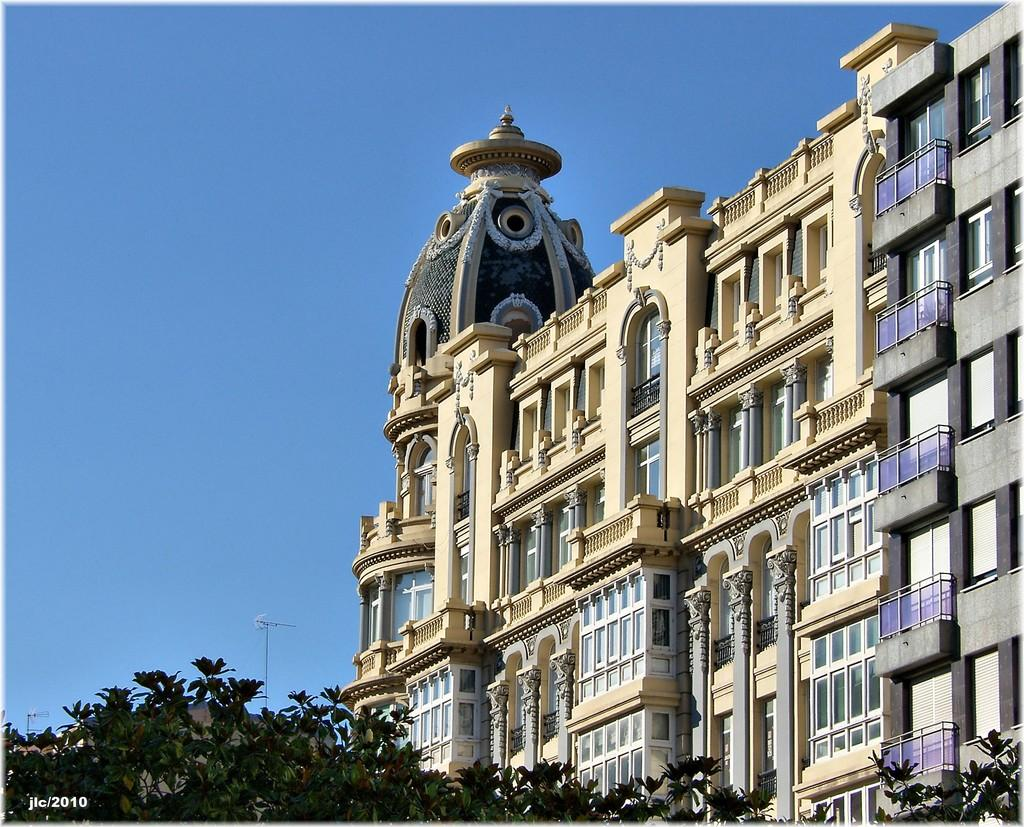What type of vegetation is present in the image? There are many trees in the image. What type of structure can be seen in the image? There is a building with windows in the image. What color is the sky in the background of the image? The blue sky is visible in the background of the image. What level of the building is shown in the image? The provided facts do not specify a level of the building, so it cannot be determined from the image. What songs are being sung by the trees in the image? There are no songs being sung by the trees in the image, as trees do not have the ability to sing. 